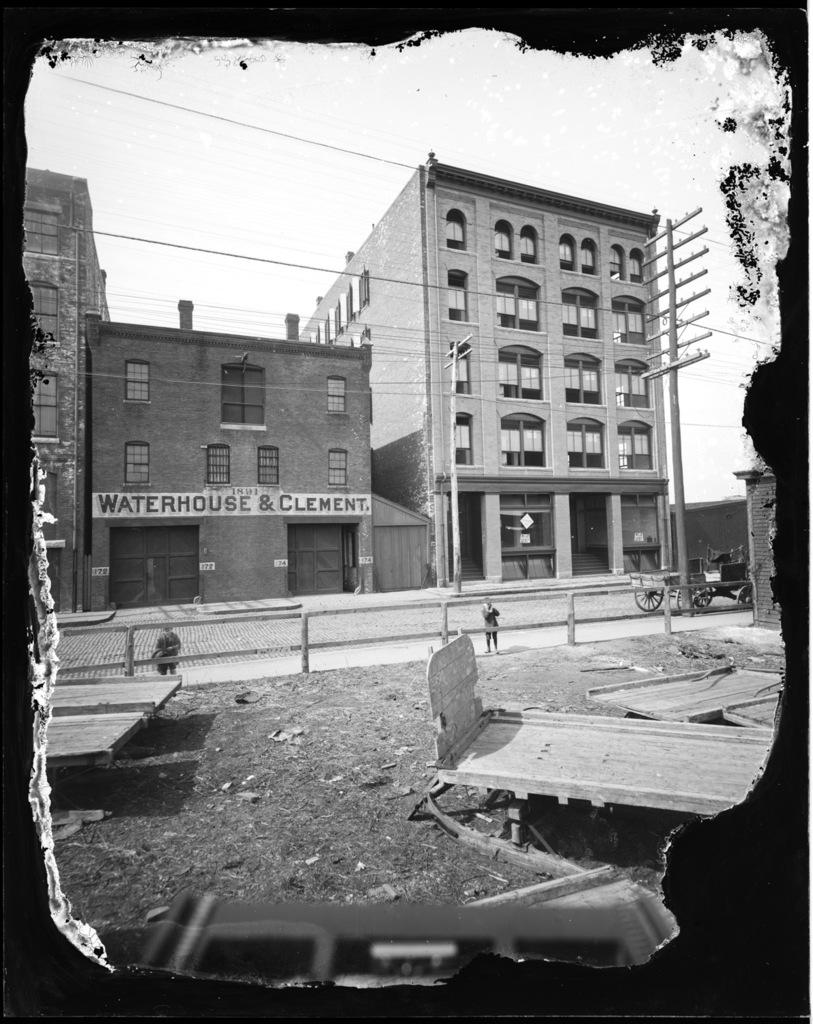What is on the road in the image? There is a vehicle on the road in the image. What can be seen near the road in the image? There is a fence in the image. What structures are visible in the image? There are buildings in the image. What are the poles in the image used for? The poles in the image are likely used for supporting cables. What else can be seen in the image besides the vehicle, fence, buildings, and poles? There are some objects in the image. What is visible in the background of the image? The sky is visible in the background of the image. What type of juice is being served in the image? There is no juice present in the image; it features a vehicle on the road, a fence, buildings, poles, cables, and objects. 